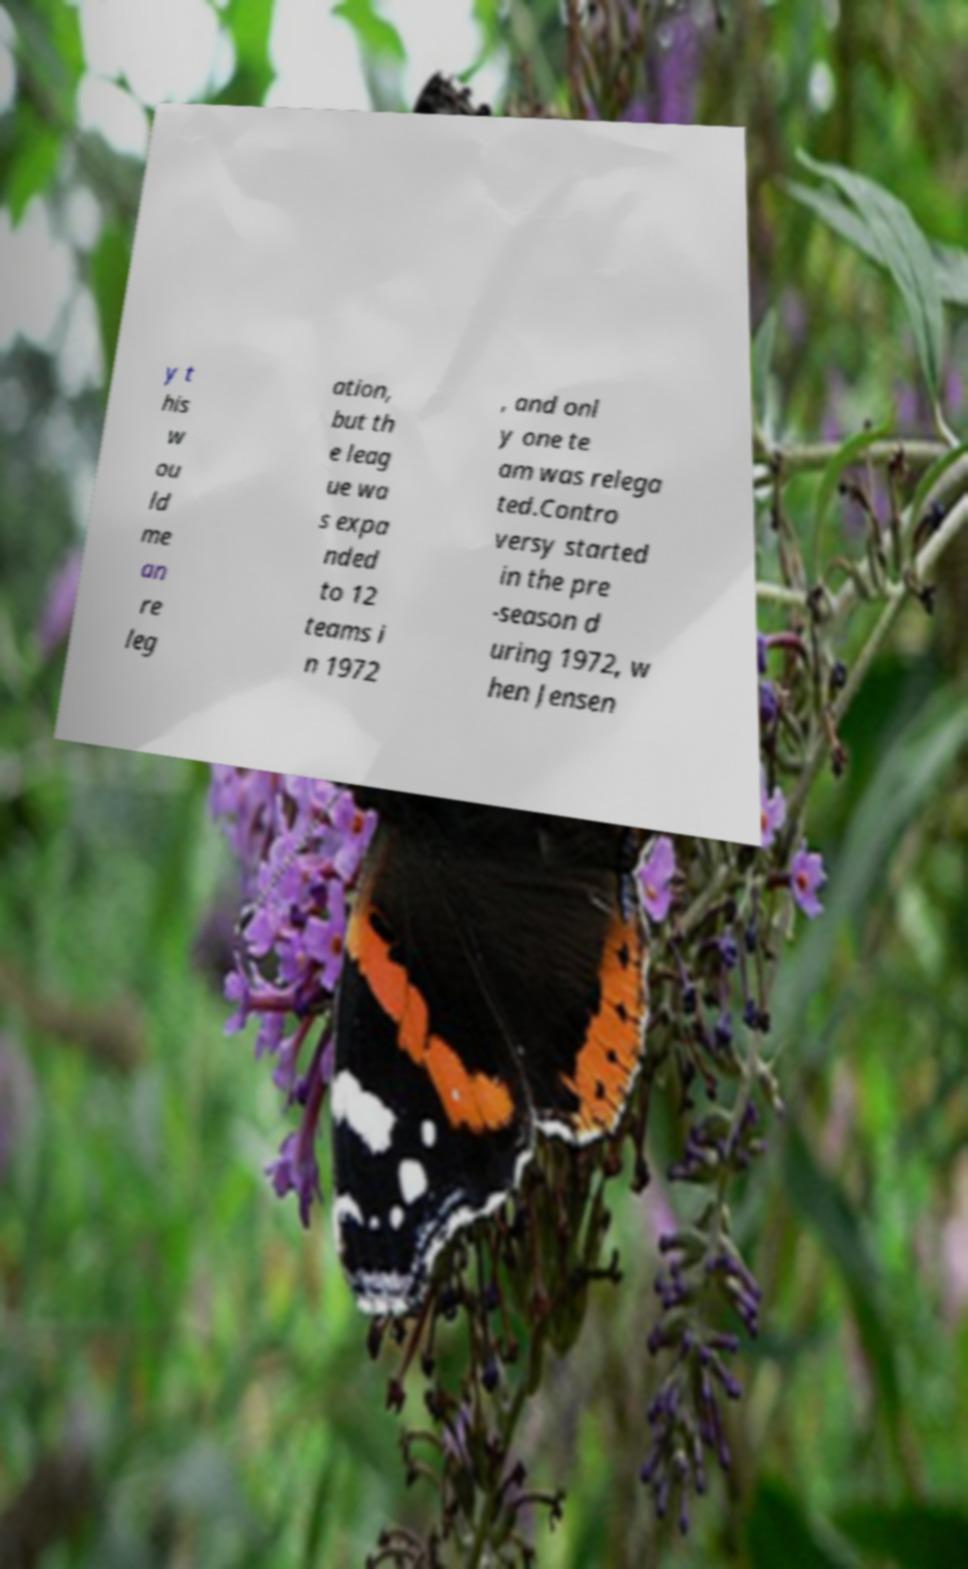Can you accurately transcribe the text from the provided image for me? y t his w ou ld me an re leg ation, but th e leag ue wa s expa nded to 12 teams i n 1972 , and onl y one te am was relega ted.Contro versy started in the pre -season d uring 1972, w hen Jensen 